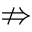<formula> <loc_0><loc_0><loc_500><loc_500>\ n R i g h t a r r o w</formula> 